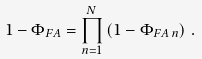<formula> <loc_0><loc_0><loc_500><loc_500>1 - \Phi _ { F A } = \prod _ { n = 1 } ^ { N } \left ( 1 - \Phi _ { F A \, n } \right ) \, .</formula> 